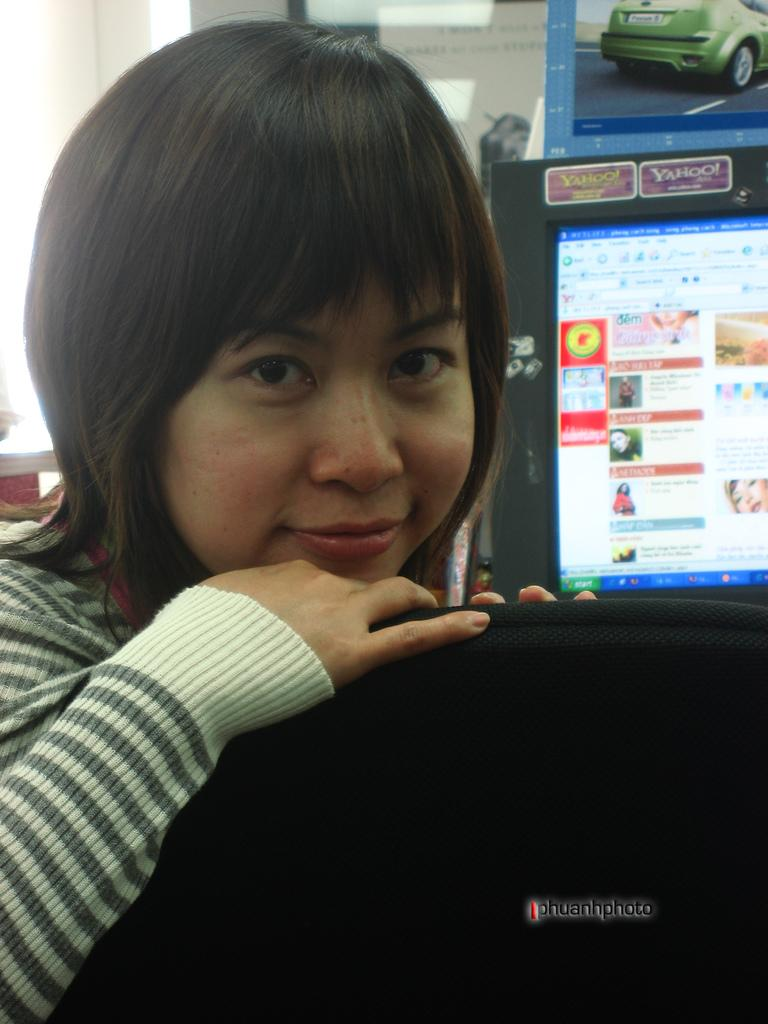Who is the main subject in the picture? There is a girl in the picture. What is the girl doing in the image? The girl is seated in the image. What is the girl's facial expression in the image? The girl is smiling in the image. What can be seen behind the girl in the image? There is a screen visible behind the girl. What type of stick is the girl holding in the image? There is no stick present in the image. Can you read the note that the girl is holding in the image? There is no note present in the image. 